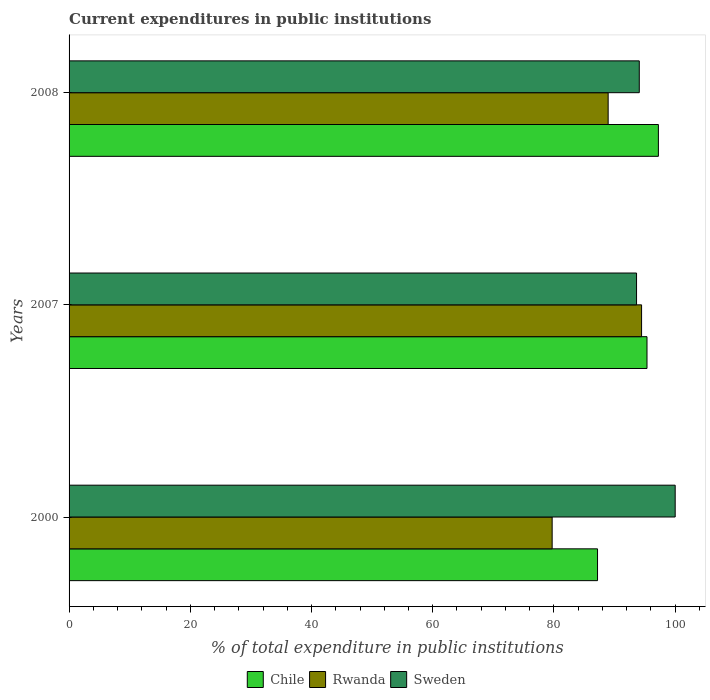Are the number of bars per tick equal to the number of legend labels?
Offer a terse response. Yes. Are the number of bars on each tick of the Y-axis equal?
Offer a very short reply. Yes. How many bars are there on the 1st tick from the bottom?
Make the answer very short. 3. In how many cases, is the number of bars for a given year not equal to the number of legend labels?
Make the answer very short. 0. What is the current expenditures in public institutions in Sweden in 2008?
Offer a very short reply. 94.08. Across all years, what is the minimum current expenditures in public institutions in Chile?
Your answer should be very brief. 87.19. In which year was the current expenditures in public institutions in Sweden maximum?
Offer a very short reply. 2000. What is the total current expenditures in public institutions in Rwanda in the graph?
Provide a short and direct response. 263.1. What is the difference between the current expenditures in public institutions in Rwanda in 2000 and that in 2008?
Keep it short and to the point. -9.24. What is the difference between the current expenditures in public institutions in Rwanda in 2008 and the current expenditures in public institutions in Chile in 2007?
Your answer should be very brief. -6.41. What is the average current expenditures in public institutions in Chile per year?
Offer a terse response. 93.26. In the year 2000, what is the difference between the current expenditures in public institutions in Chile and current expenditures in public institutions in Sweden?
Your answer should be compact. -12.81. What is the ratio of the current expenditures in public institutions in Sweden in 2000 to that in 2007?
Your answer should be compact. 1.07. What is the difference between the highest and the second highest current expenditures in public institutions in Rwanda?
Offer a very short reply. 5.51. What is the difference between the highest and the lowest current expenditures in public institutions in Rwanda?
Ensure brevity in your answer.  14.75. In how many years, is the current expenditures in public institutions in Rwanda greater than the average current expenditures in public institutions in Rwanda taken over all years?
Your answer should be very brief. 2. Is the sum of the current expenditures in public institutions in Sweden in 2000 and 2008 greater than the maximum current expenditures in public institutions in Chile across all years?
Provide a short and direct response. Yes. What does the 1st bar from the top in 2000 represents?
Keep it short and to the point. Sweden. How many bars are there?
Keep it short and to the point. 9. Are all the bars in the graph horizontal?
Your response must be concise. Yes. What is the difference between two consecutive major ticks on the X-axis?
Your response must be concise. 20. Where does the legend appear in the graph?
Your response must be concise. Bottom center. How are the legend labels stacked?
Make the answer very short. Horizontal. What is the title of the graph?
Make the answer very short. Current expenditures in public institutions. Does "Grenada" appear as one of the legend labels in the graph?
Offer a very short reply. No. What is the label or title of the X-axis?
Make the answer very short. % of total expenditure in public institutions. What is the % of total expenditure in public institutions of Chile in 2000?
Your response must be concise. 87.19. What is the % of total expenditure in public institutions in Rwanda in 2000?
Provide a succinct answer. 79.7. What is the % of total expenditure in public institutions in Sweden in 2000?
Keep it short and to the point. 100. What is the % of total expenditure in public institutions in Chile in 2007?
Your response must be concise. 95.35. What is the % of total expenditure in public institutions of Rwanda in 2007?
Provide a succinct answer. 94.45. What is the % of total expenditure in public institutions of Sweden in 2007?
Keep it short and to the point. 93.62. What is the % of total expenditure in public institutions of Chile in 2008?
Offer a terse response. 97.23. What is the % of total expenditure in public institutions of Rwanda in 2008?
Make the answer very short. 88.94. What is the % of total expenditure in public institutions in Sweden in 2008?
Your answer should be very brief. 94.08. Across all years, what is the maximum % of total expenditure in public institutions of Chile?
Keep it short and to the point. 97.23. Across all years, what is the maximum % of total expenditure in public institutions in Rwanda?
Your answer should be very brief. 94.45. Across all years, what is the maximum % of total expenditure in public institutions of Sweden?
Give a very brief answer. 100. Across all years, what is the minimum % of total expenditure in public institutions in Chile?
Give a very brief answer. 87.19. Across all years, what is the minimum % of total expenditure in public institutions in Rwanda?
Your answer should be very brief. 79.7. Across all years, what is the minimum % of total expenditure in public institutions in Sweden?
Keep it short and to the point. 93.62. What is the total % of total expenditure in public institutions of Chile in the graph?
Your answer should be very brief. 279.77. What is the total % of total expenditure in public institutions in Rwanda in the graph?
Keep it short and to the point. 263.1. What is the total % of total expenditure in public institutions of Sweden in the graph?
Keep it short and to the point. 287.7. What is the difference between the % of total expenditure in public institutions of Chile in 2000 and that in 2007?
Make the answer very short. -8.16. What is the difference between the % of total expenditure in public institutions in Rwanda in 2000 and that in 2007?
Make the answer very short. -14.75. What is the difference between the % of total expenditure in public institutions of Sweden in 2000 and that in 2007?
Give a very brief answer. 6.38. What is the difference between the % of total expenditure in public institutions in Chile in 2000 and that in 2008?
Give a very brief answer. -10.04. What is the difference between the % of total expenditure in public institutions of Rwanda in 2000 and that in 2008?
Offer a terse response. -9.24. What is the difference between the % of total expenditure in public institutions of Sweden in 2000 and that in 2008?
Keep it short and to the point. 5.92. What is the difference between the % of total expenditure in public institutions of Chile in 2007 and that in 2008?
Provide a short and direct response. -1.88. What is the difference between the % of total expenditure in public institutions of Rwanda in 2007 and that in 2008?
Offer a terse response. 5.51. What is the difference between the % of total expenditure in public institutions of Sweden in 2007 and that in 2008?
Your answer should be very brief. -0.45. What is the difference between the % of total expenditure in public institutions in Chile in 2000 and the % of total expenditure in public institutions in Rwanda in 2007?
Provide a short and direct response. -7.27. What is the difference between the % of total expenditure in public institutions of Chile in 2000 and the % of total expenditure in public institutions of Sweden in 2007?
Offer a terse response. -6.44. What is the difference between the % of total expenditure in public institutions in Rwanda in 2000 and the % of total expenditure in public institutions in Sweden in 2007?
Your response must be concise. -13.92. What is the difference between the % of total expenditure in public institutions of Chile in 2000 and the % of total expenditure in public institutions of Rwanda in 2008?
Keep it short and to the point. -1.75. What is the difference between the % of total expenditure in public institutions in Chile in 2000 and the % of total expenditure in public institutions in Sweden in 2008?
Your answer should be compact. -6.89. What is the difference between the % of total expenditure in public institutions of Rwanda in 2000 and the % of total expenditure in public institutions of Sweden in 2008?
Provide a short and direct response. -14.37. What is the difference between the % of total expenditure in public institutions in Chile in 2007 and the % of total expenditure in public institutions in Rwanda in 2008?
Give a very brief answer. 6.41. What is the difference between the % of total expenditure in public institutions in Chile in 2007 and the % of total expenditure in public institutions in Sweden in 2008?
Your answer should be compact. 1.27. What is the difference between the % of total expenditure in public institutions of Rwanda in 2007 and the % of total expenditure in public institutions of Sweden in 2008?
Provide a short and direct response. 0.38. What is the average % of total expenditure in public institutions of Chile per year?
Keep it short and to the point. 93.26. What is the average % of total expenditure in public institutions in Rwanda per year?
Your answer should be compact. 87.7. What is the average % of total expenditure in public institutions in Sweden per year?
Your answer should be compact. 95.9. In the year 2000, what is the difference between the % of total expenditure in public institutions of Chile and % of total expenditure in public institutions of Rwanda?
Give a very brief answer. 7.49. In the year 2000, what is the difference between the % of total expenditure in public institutions of Chile and % of total expenditure in public institutions of Sweden?
Your answer should be very brief. -12.81. In the year 2000, what is the difference between the % of total expenditure in public institutions in Rwanda and % of total expenditure in public institutions in Sweden?
Give a very brief answer. -20.3. In the year 2007, what is the difference between the % of total expenditure in public institutions in Chile and % of total expenditure in public institutions in Rwanda?
Your response must be concise. 0.89. In the year 2007, what is the difference between the % of total expenditure in public institutions of Chile and % of total expenditure in public institutions of Sweden?
Provide a succinct answer. 1.73. In the year 2007, what is the difference between the % of total expenditure in public institutions in Rwanda and % of total expenditure in public institutions in Sweden?
Your answer should be very brief. 0.83. In the year 2008, what is the difference between the % of total expenditure in public institutions of Chile and % of total expenditure in public institutions of Rwanda?
Ensure brevity in your answer.  8.29. In the year 2008, what is the difference between the % of total expenditure in public institutions of Chile and % of total expenditure in public institutions of Sweden?
Offer a very short reply. 3.15. In the year 2008, what is the difference between the % of total expenditure in public institutions in Rwanda and % of total expenditure in public institutions in Sweden?
Give a very brief answer. -5.13. What is the ratio of the % of total expenditure in public institutions in Chile in 2000 to that in 2007?
Give a very brief answer. 0.91. What is the ratio of the % of total expenditure in public institutions in Rwanda in 2000 to that in 2007?
Provide a succinct answer. 0.84. What is the ratio of the % of total expenditure in public institutions in Sweden in 2000 to that in 2007?
Give a very brief answer. 1.07. What is the ratio of the % of total expenditure in public institutions of Chile in 2000 to that in 2008?
Your answer should be compact. 0.9. What is the ratio of the % of total expenditure in public institutions of Rwanda in 2000 to that in 2008?
Give a very brief answer. 0.9. What is the ratio of the % of total expenditure in public institutions of Sweden in 2000 to that in 2008?
Offer a terse response. 1.06. What is the ratio of the % of total expenditure in public institutions of Chile in 2007 to that in 2008?
Offer a very short reply. 0.98. What is the ratio of the % of total expenditure in public institutions in Rwanda in 2007 to that in 2008?
Make the answer very short. 1.06. What is the ratio of the % of total expenditure in public institutions of Sweden in 2007 to that in 2008?
Make the answer very short. 1. What is the difference between the highest and the second highest % of total expenditure in public institutions in Chile?
Offer a terse response. 1.88. What is the difference between the highest and the second highest % of total expenditure in public institutions of Rwanda?
Offer a terse response. 5.51. What is the difference between the highest and the second highest % of total expenditure in public institutions in Sweden?
Provide a succinct answer. 5.92. What is the difference between the highest and the lowest % of total expenditure in public institutions of Chile?
Provide a short and direct response. 10.04. What is the difference between the highest and the lowest % of total expenditure in public institutions of Rwanda?
Your answer should be compact. 14.75. What is the difference between the highest and the lowest % of total expenditure in public institutions of Sweden?
Provide a short and direct response. 6.38. 